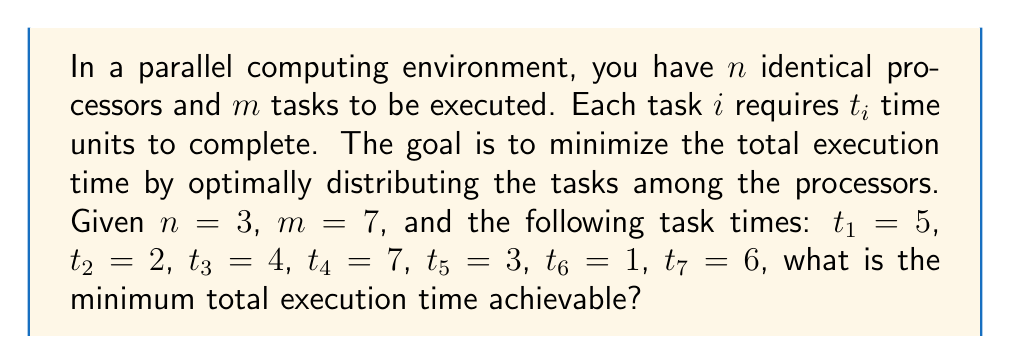Could you help me with this problem? To solve this optimization problem, we can use a greedy approach known as the Longest Processing Time (LPT) algorithm. This algorithm is well-suited for quick implementation in coding competitions and often provides a good approximation of the optimal solution.

The steps to solve this problem are:

1) Sort the tasks in descending order of processing time:
   $t_4 = 7$, $t_7 = 6$, $t_1 = 5$, $t_3 = 4$, $t_5 = 3$, $t_2 = 2$, $t_6 = 1$

2) Assign tasks to processors in this order, always choosing the processor with the least current load:

   Processor 1: 7
   Processor 2: 6
   Processor 3: 5

   Processor 1: 7
   Processor 2: 6
   Processor 3: 5 + 4 = 9

   Processor 1: 7 + 3 = 10
   Processor 2: 6 + 2 = 8
   Processor 3: 9

   Processor 1: 10
   Processor 2: 8 + 1 = 9
   Processor 3: 9

3) The total execution time is determined by the processor with the highest load, which in this case is Processor 1 with a load of 10.

This approach ensures that larger tasks are distributed first, reducing the likelihood of having a single large task dominating the execution time on one processor.
Answer: The minimum total execution time achievable is 10 time units. 